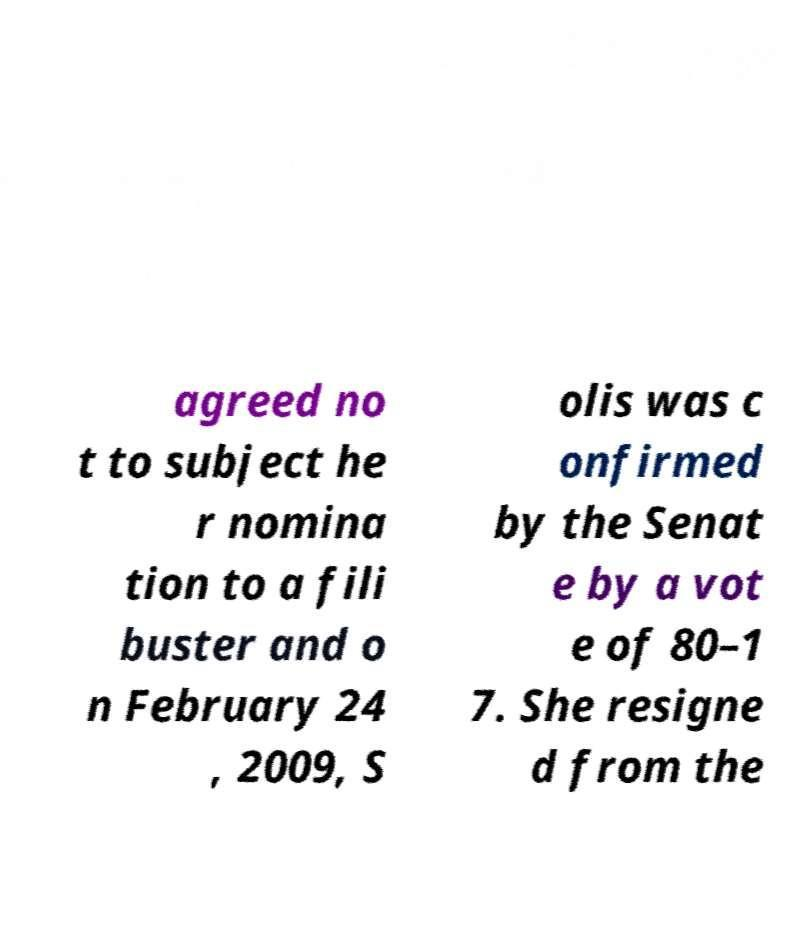Could you assist in decoding the text presented in this image and type it out clearly? agreed no t to subject he r nomina tion to a fili buster and o n February 24 , 2009, S olis was c onfirmed by the Senat e by a vot e of 80–1 7. She resigne d from the 